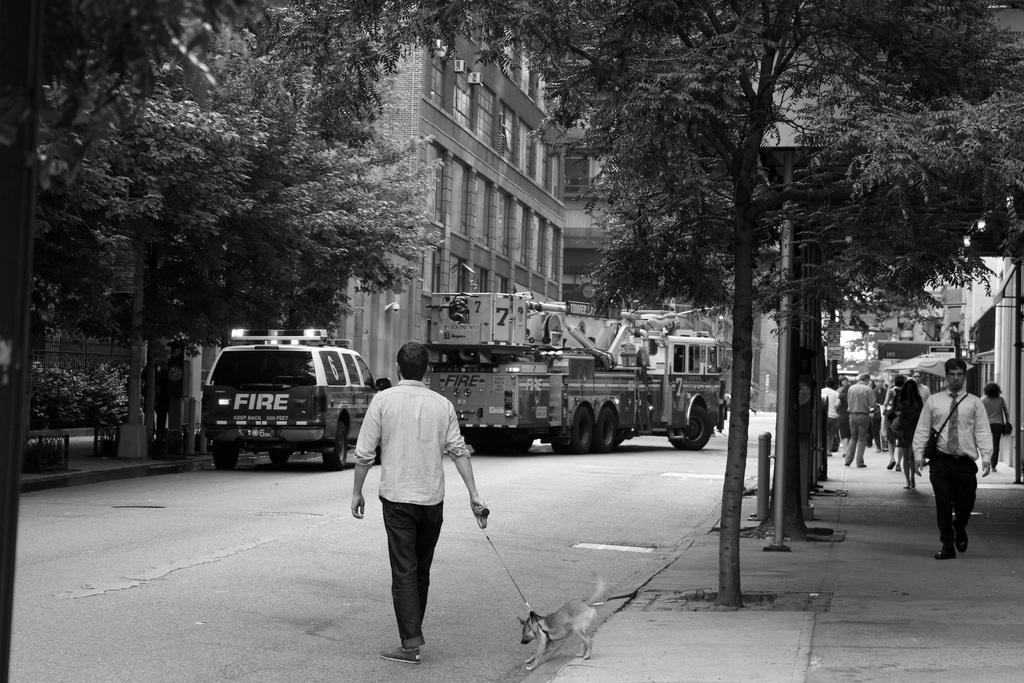What can be seen in the foreground of the image? In the foreground of the image, there are vehicles, a crowd, and a dog on the road. What is visible in the background of the image? In the background of the image, there are trees, buildings, and windows. What time of day was the image taken? The image was taken during the day. Can you tell me how many goldfish are swimming in the windows in the background of the image? There are no goldfish present in the image; the windows are part of the buildings in the background. What rule is being enforced by the crowd in the foreground of the image? There is no indication of a rule being enforced in the image; the crowd is simply present in the foreground. 